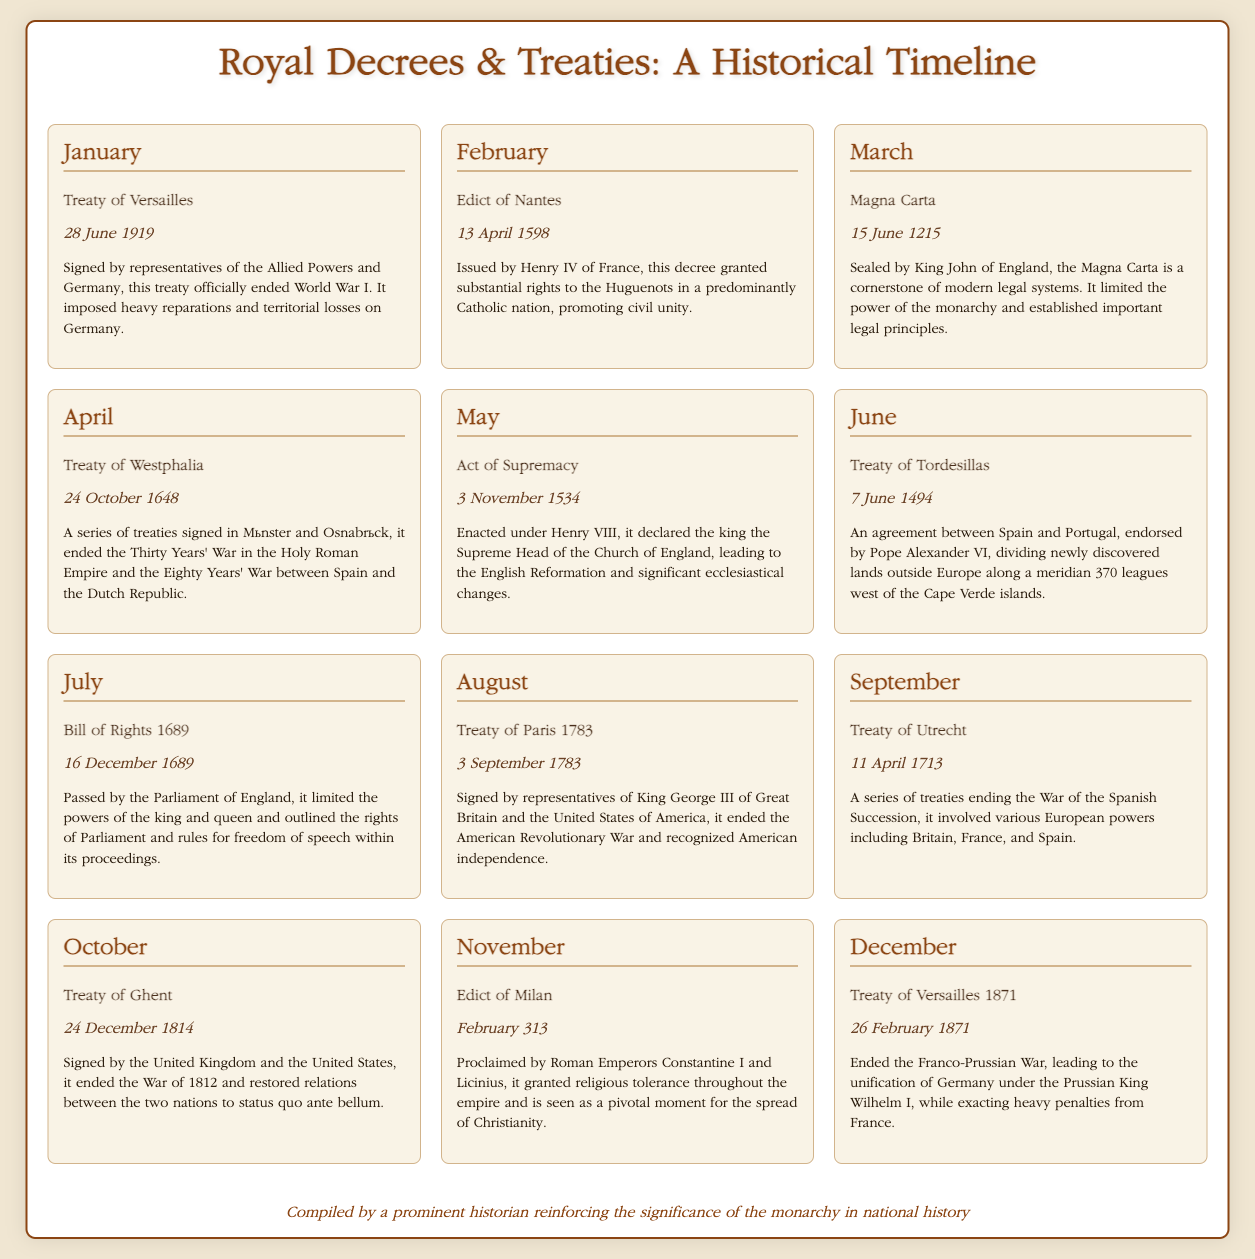What treaty officially ended World War I? The document lists the treaty signed on 28 June 1919, which is the Treaty of Versailles that officially ended World War I.
Answer: Treaty of Versailles Who issued the Edict of Nantes? According to February's entry, this decree was issued by Henry IV of France.
Answer: Henry IV What significant document was sealed on 15 June 1215? The document highlights that this date corresponds to the sealing of the Magna Carta, a cornerstone of legal systems.
Answer: Magna Carta On what date was the Treaty of Ghent signed? The document specifies that the Treaty of Ghent was signed on 24 December 1814.
Answer: 24 December 1814 What was the main outcome of the Treaty of Paris 1783? Based on the document's description, it ended the American Revolutionary War and recognized American independence.
Answer: Recognized American independence Which event was enacted under Henry VIII? The document indicates that the Act of Supremacy, which declared the king the Supreme Head of the Church of England, was enacted under Henry VIII.
Answer: Act of Supremacy How many months are covered in the timeline? The document presents events across twelve months, from January to December.
Answer: Twelve months What key principle did the Magna Carta establish? The document notes that the Magna Carta limited the power of the monarchy and established important legal principles.
Answer: Limited the power of the monarchy What year did the Edict of Milan occur? The document specifies the Edict of Milan took place in February 313.
Answer: February 313 